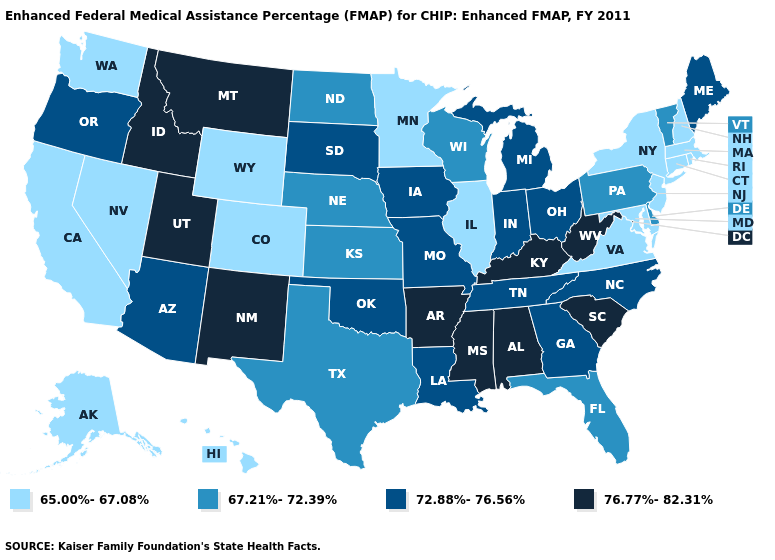Does the map have missing data?
Short answer required. No. What is the lowest value in states that border Idaho?
Give a very brief answer. 65.00%-67.08%. Does Rhode Island have the lowest value in the USA?
Give a very brief answer. Yes. Name the states that have a value in the range 65.00%-67.08%?
Quick response, please. Alaska, California, Colorado, Connecticut, Hawaii, Illinois, Maryland, Massachusetts, Minnesota, Nevada, New Hampshire, New Jersey, New York, Rhode Island, Virginia, Washington, Wyoming. Name the states that have a value in the range 72.88%-76.56%?
Keep it brief. Arizona, Georgia, Indiana, Iowa, Louisiana, Maine, Michigan, Missouri, North Carolina, Ohio, Oklahoma, Oregon, South Dakota, Tennessee. Name the states that have a value in the range 65.00%-67.08%?
Short answer required. Alaska, California, Colorado, Connecticut, Hawaii, Illinois, Maryland, Massachusetts, Minnesota, Nevada, New Hampshire, New Jersey, New York, Rhode Island, Virginia, Washington, Wyoming. Which states have the highest value in the USA?
Be succinct. Alabama, Arkansas, Idaho, Kentucky, Mississippi, Montana, New Mexico, South Carolina, Utah, West Virginia. Which states have the highest value in the USA?
Quick response, please. Alabama, Arkansas, Idaho, Kentucky, Mississippi, Montana, New Mexico, South Carolina, Utah, West Virginia. Name the states that have a value in the range 65.00%-67.08%?
Quick response, please. Alaska, California, Colorado, Connecticut, Hawaii, Illinois, Maryland, Massachusetts, Minnesota, Nevada, New Hampshire, New Jersey, New York, Rhode Island, Virginia, Washington, Wyoming. Does New York have a higher value than Tennessee?
Be succinct. No. Does Nevada have a lower value than Texas?
Short answer required. Yes. Name the states that have a value in the range 65.00%-67.08%?
Answer briefly. Alaska, California, Colorado, Connecticut, Hawaii, Illinois, Maryland, Massachusetts, Minnesota, Nevada, New Hampshire, New Jersey, New York, Rhode Island, Virginia, Washington, Wyoming. What is the lowest value in the South?
Short answer required. 65.00%-67.08%. Does the first symbol in the legend represent the smallest category?
Short answer required. Yes. Does Minnesota have the lowest value in the USA?
Keep it brief. Yes. 